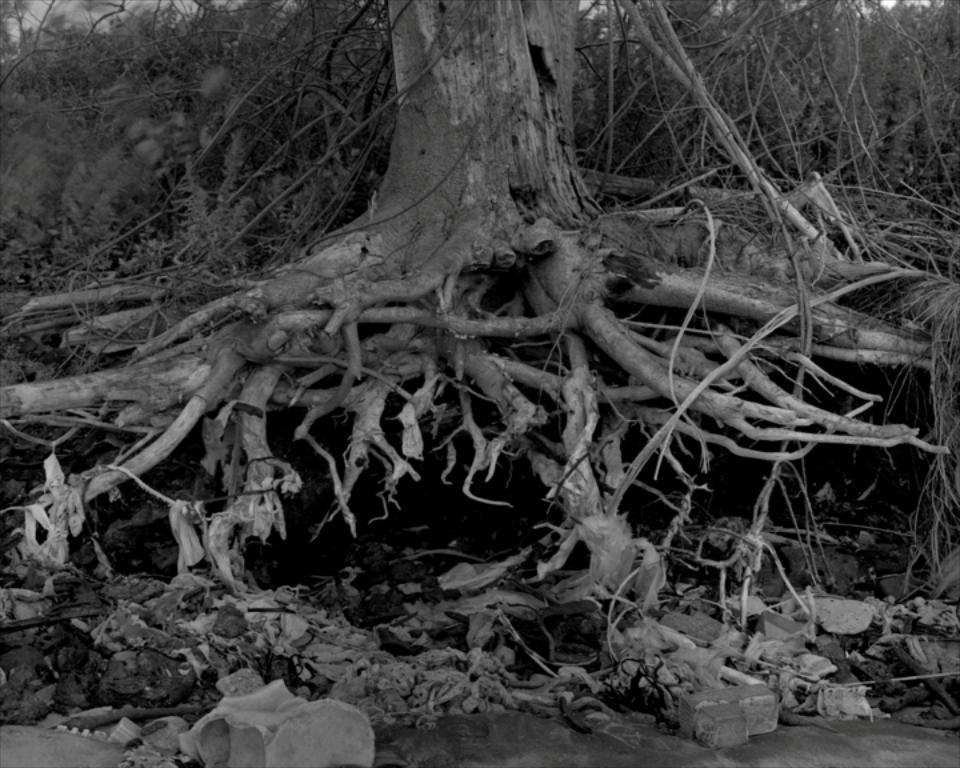What type of plant is featured in the image? There is a tree with roots in the image. What other objects can be seen in the image? There are stones visible in the image. What is visible in the background of the image? There are plants in the background of the image. How is the image presented in terms of color? The image is black and white. What type of business is being conducted in the image? There is no indication of any business activity in the image; it features a tree with roots, stones, and plants in the background. 